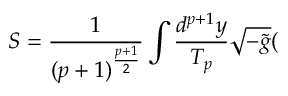<formula> <loc_0><loc_0><loc_500><loc_500>S = \frac { 1 } ( p + 1 ) ^ { \frac { p + 1 } 2 } } \int \frac { d ^ { p + 1 } y } { T _ { p } } \sqrt { - \tilde { g } } (</formula> 